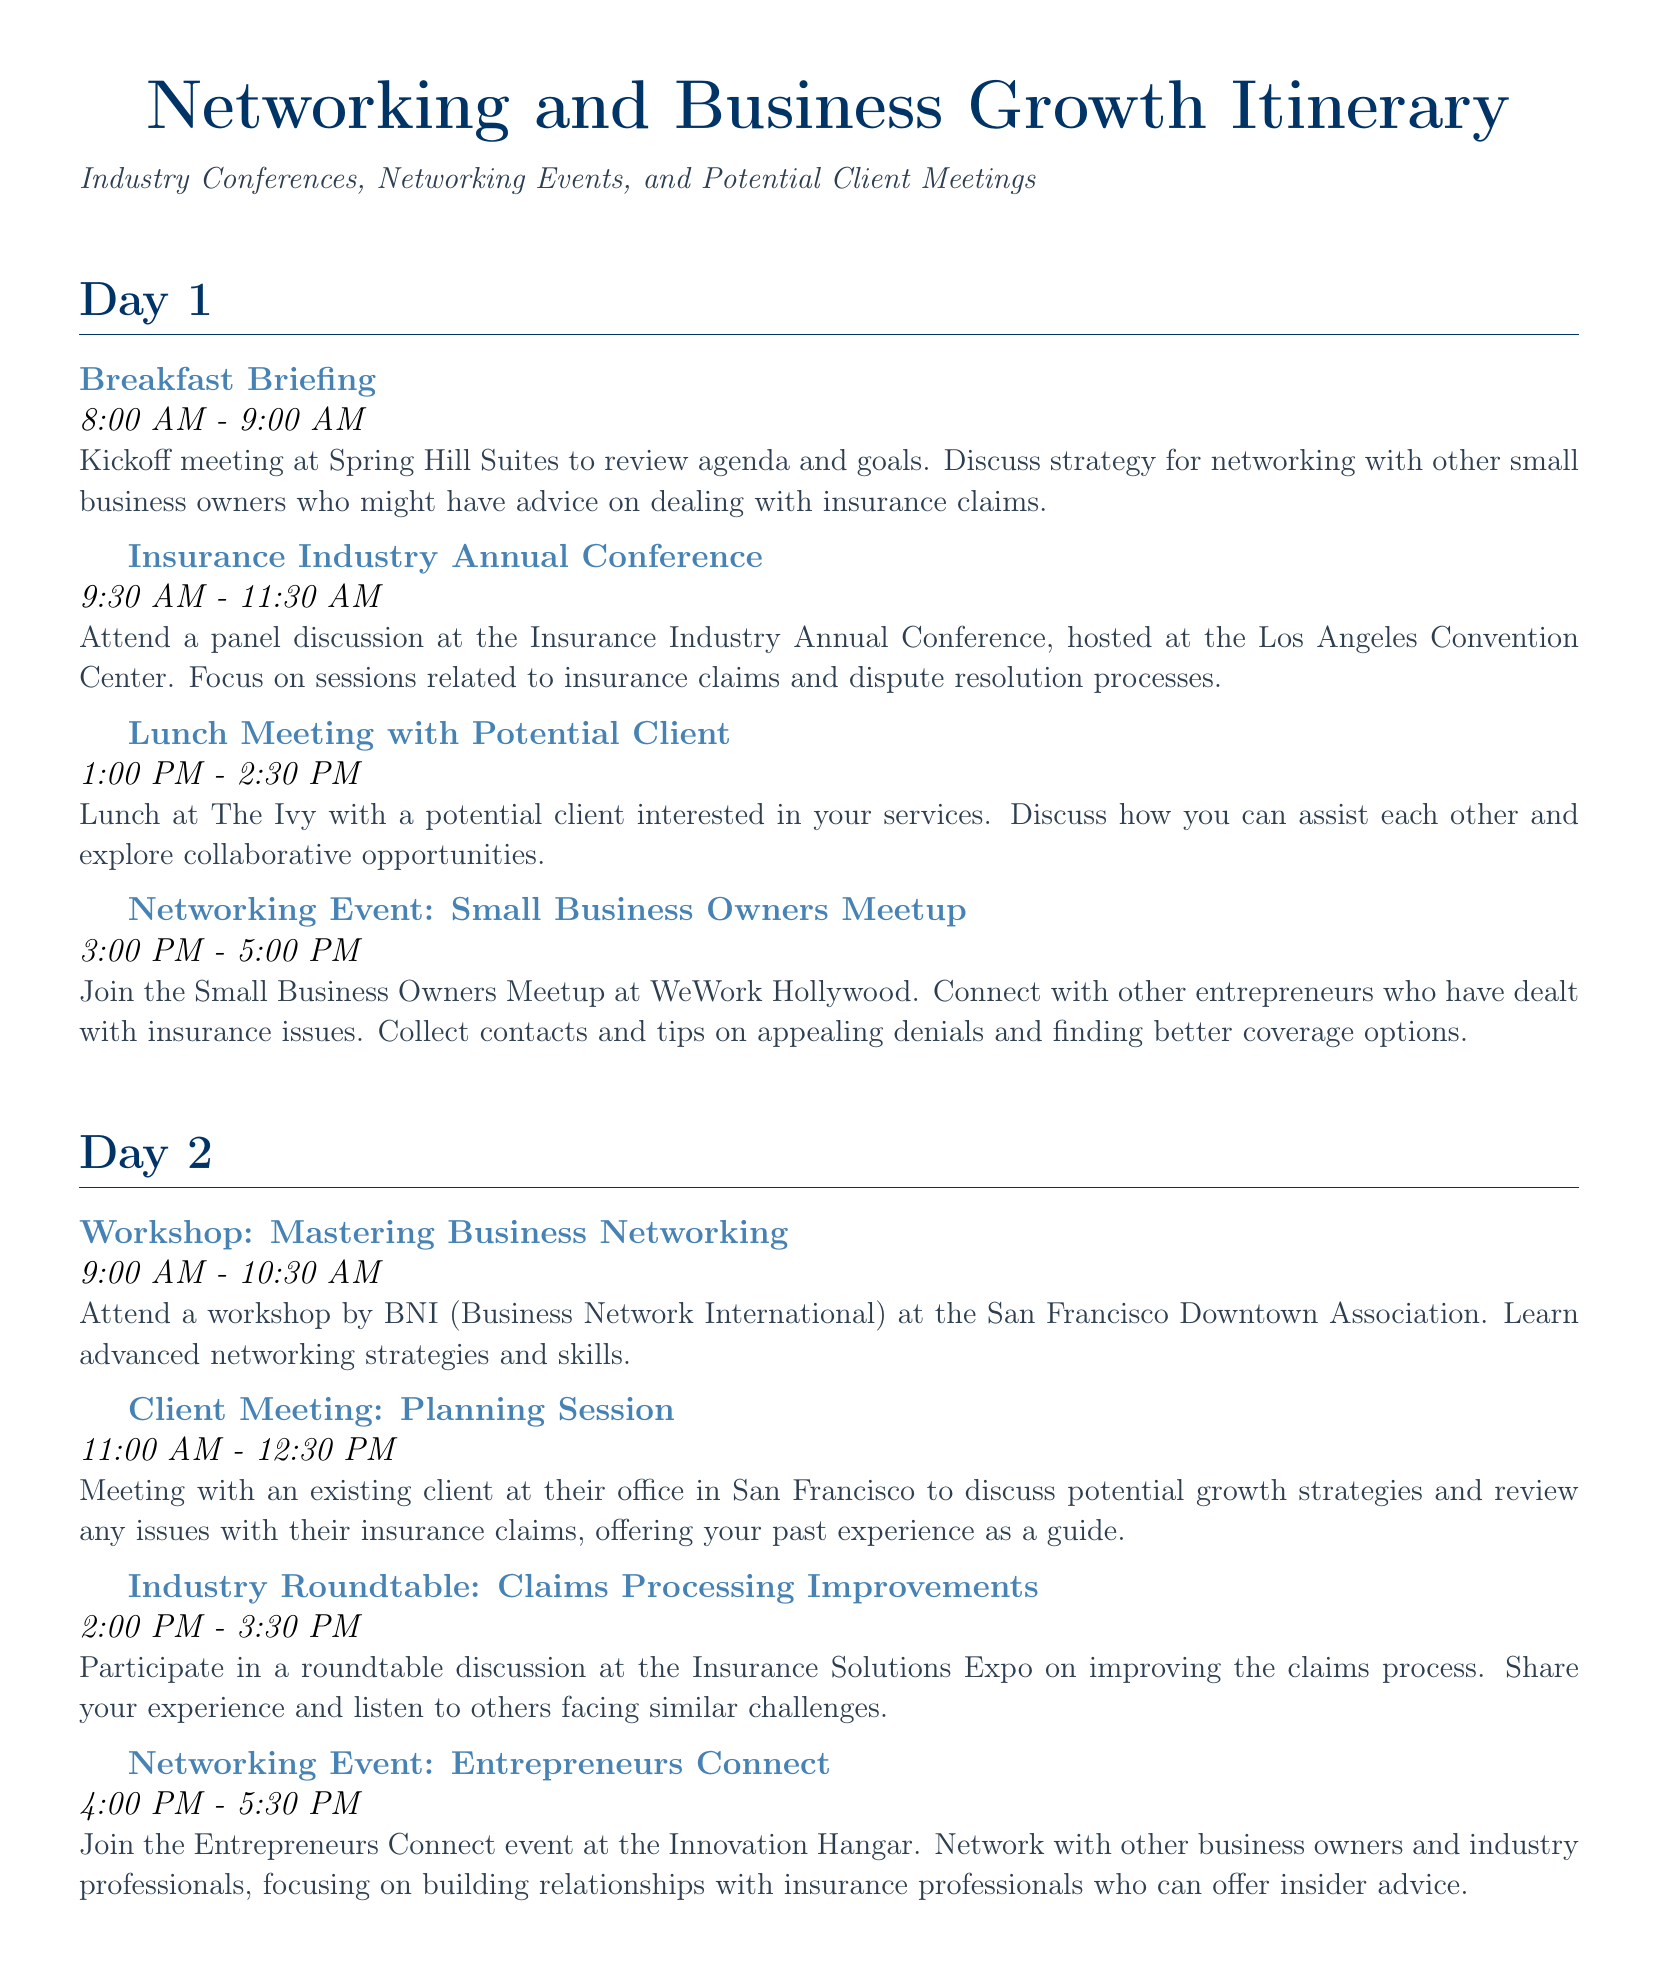What is the location of the Insurance Industry Annual Conference? The location of the Insurance Industry Annual Conference is specified as the Los Angeles Convention Center in the document.
Answer: Los Angeles Convention Center What time does the Small Business Owners Meetup start? The document indicates that the Small Business Owners Meetup starts at 3:00 PM.
Answer: 3:00 PM Who is hosting the Workshop: Legal Aspects of Insurance Claims? The document states that the American Bar Association is hosting the workshop.
Answer: American Bar Association What is the purpose of the breakfast meeting with the adjuster? The purpose is to seek tailored advice on how to appeal the insurance denial, as mentioned in the document.
Answer: Appeal denial How many days does the itinerary cover? The itinerary outlines events across three days.
Answer: Three days What type of session follows the breakfast meeting on Day 3? The document states that the next session is a Trade Show after the breakfast meeting.
Answer: Trade Show At which event will participants discuss potential collaboration? The participants will discuss potential collaboration at the Closing Networking Event.
Answer: Closing Networking Event What is the duration of the workshop on Mastering Business Networking? The document notes that the workshop duration is 1.5 hours, from 9:00 AM to 10:30 AM.
Answer: 1.5 hours When is the Client Meeting: Planning Session scheduled? The document specifies that the Client Meeting is scheduled for 11:00 AM to 12:30 PM on Day 2.
Answer: 11:00 AM - 12:30 PM 